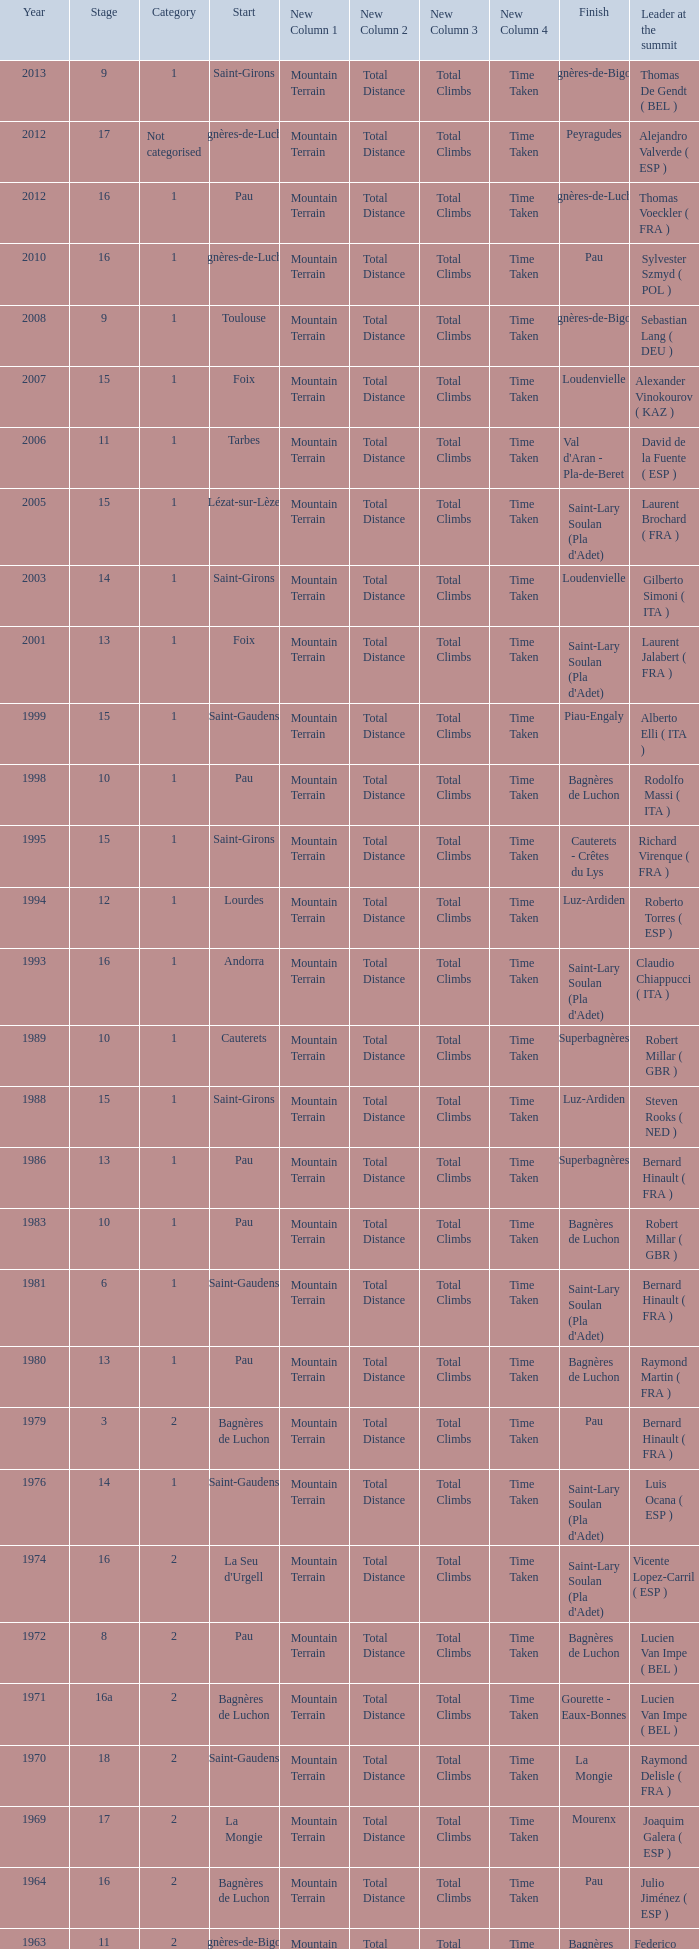What category was in 1964? 2.0. 